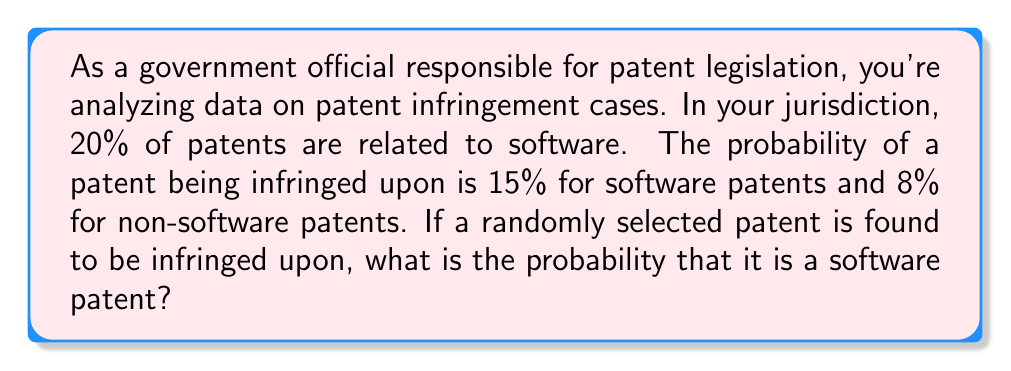Could you help me with this problem? Let's approach this using conditional probability and Bayes' theorem.

Define the events:
S: The patent is software-related
I: The patent is infringed upon

Given:
P(S) = 0.20 (20% of patents are software-related)
P(I|S) = 0.15 (15% probability of infringement for software patents)
P(I|not S) = 0.08 (8% probability of infringement for non-software patents)

We want to find P(S|I), the probability that a patent is software-related given that it's infringed upon.

Using Bayes' theorem:

$$ P(S|I) = \frac{P(I|S) \cdot P(S)}{P(I)} $$

We need to calculate P(I) using the law of total probability:

$$ P(I) = P(I|S) \cdot P(S) + P(I|not S) \cdot P(not S) $$

$$ P(I) = 0.15 \cdot 0.20 + 0.08 \cdot 0.80 $$
$$ P(I) = 0.03 + 0.064 = 0.094 $$

Now we can apply Bayes' theorem:

$$ P(S|I) = \frac{0.15 \cdot 0.20}{0.094} \approx 0.3191 $$
Answer: The probability that an infringed patent is a software patent is approximately 0.3191 or 31.91%. 